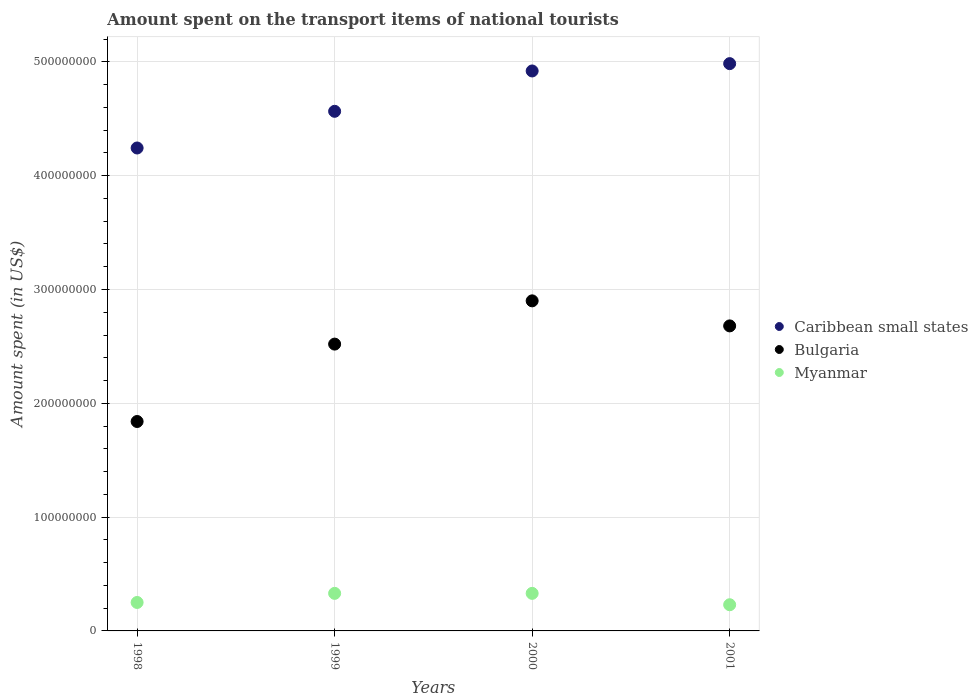What is the amount spent on the transport items of national tourists in Myanmar in 1999?
Keep it short and to the point. 3.30e+07. Across all years, what is the maximum amount spent on the transport items of national tourists in Myanmar?
Offer a terse response. 3.30e+07. Across all years, what is the minimum amount spent on the transport items of national tourists in Caribbean small states?
Make the answer very short. 4.24e+08. What is the total amount spent on the transport items of national tourists in Myanmar in the graph?
Give a very brief answer. 1.14e+08. What is the difference between the amount spent on the transport items of national tourists in Bulgaria in 1998 and that in 2000?
Your response must be concise. -1.06e+08. What is the difference between the amount spent on the transport items of national tourists in Caribbean small states in 1998 and the amount spent on the transport items of national tourists in Bulgaria in 2001?
Your answer should be very brief. 1.56e+08. What is the average amount spent on the transport items of national tourists in Myanmar per year?
Make the answer very short. 2.85e+07. In the year 2001, what is the difference between the amount spent on the transport items of national tourists in Caribbean small states and amount spent on the transport items of national tourists in Myanmar?
Provide a short and direct response. 4.75e+08. In how many years, is the amount spent on the transport items of national tourists in Myanmar greater than 120000000 US$?
Provide a short and direct response. 0. What is the ratio of the amount spent on the transport items of national tourists in Myanmar in 1998 to that in 1999?
Offer a very short reply. 0.76. Is the difference between the amount spent on the transport items of national tourists in Caribbean small states in 1998 and 2001 greater than the difference between the amount spent on the transport items of national tourists in Myanmar in 1998 and 2001?
Give a very brief answer. No. What is the difference between the highest and the second highest amount spent on the transport items of national tourists in Caribbean small states?
Your response must be concise. 6.45e+06. What is the difference between the highest and the lowest amount spent on the transport items of national tourists in Bulgaria?
Offer a very short reply. 1.06e+08. Is the sum of the amount spent on the transport items of national tourists in Myanmar in 1999 and 2001 greater than the maximum amount spent on the transport items of national tourists in Bulgaria across all years?
Give a very brief answer. No. Is it the case that in every year, the sum of the amount spent on the transport items of national tourists in Myanmar and amount spent on the transport items of national tourists in Caribbean small states  is greater than the amount spent on the transport items of national tourists in Bulgaria?
Keep it short and to the point. Yes. Is the amount spent on the transport items of national tourists in Bulgaria strictly less than the amount spent on the transport items of national tourists in Myanmar over the years?
Your response must be concise. No. How many dotlines are there?
Make the answer very short. 3. How many years are there in the graph?
Offer a very short reply. 4. Where does the legend appear in the graph?
Provide a succinct answer. Center right. How many legend labels are there?
Your answer should be compact. 3. How are the legend labels stacked?
Offer a very short reply. Vertical. What is the title of the graph?
Make the answer very short. Amount spent on the transport items of national tourists. What is the label or title of the X-axis?
Provide a short and direct response. Years. What is the label or title of the Y-axis?
Ensure brevity in your answer.  Amount spent (in US$). What is the Amount spent (in US$) of Caribbean small states in 1998?
Offer a terse response. 4.24e+08. What is the Amount spent (in US$) of Bulgaria in 1998?
Provide a short and direct response. 1.84e+08. What is the Amount spent (in US$) of Myanmar in 1998?
Provide a succinct answer. 2.50e+07. What is the Amount spent (in US$) in Caribbean small states in 1999?
Keep it short and to the point. 4.57e+08. What is the Amount spent (in US$) in Bulgaria in 1999?
Your answer should be compact. 2.52e+08. What is the Amount spent (in US$) in Myanmar in 1999?
Ensure brevity in your answer.  3.30e+07. What is the Amount spent (in US$) in Caribbean small states in 2000?
Offer a terse response. 4.92e+08. What is the Amount spent (in US$) in Bulgaria in 2000?
Your answer should be very brief. 2.90e+08. What is the Amount spent (in US$) in Myanmar in 2000?
Make the answer very short. 3.30e+07. What is the Amount spent (in US$) in Caribbean small states in 2001?
Ensure brevity in your answer.  4.98e+08. What is the Amount spent (in US$) of Bulgaria in 2001?
Keep it short and to the point. 2.68e+08. What is the Amount spent (in US$) in Myanmar in 2001?
Provide a short and direct response. 2.30e+07. Across all years, what is the maximum Amount spent (in US$) in Caribbean small states?
Your answer should be compact. 4.98e+08. Across all years, what is the maximum Amount spent (in US$) in Bulgaria?
Keep it short and to the point. 2.90e+08. Across all years, what is the maximum Amount spent (in US$) of Myanmar?
Offer a terse response. 3.30e+07. Across all years, what is the minimum Amount spent (in US$) in Caribbean small states?
Provide a short and direct response. 4.24e+08. Across all years, what is the minimum Amount spent (in US$) of Bulgaria?
Offer a terse response. 1.84e+08. Across all years, what is the minimum Amount spent (in US$) in Myanmar?
Provide a short and direct response. 2.30e+07. What is the total Amount spent (in US$) of Caribbean small states in the graph?
Your answer should be very brief. 1.87e+09. What is the total Amount spent (in US$) of Bulgaria in the graph?
Provide a short and direct response. 9.94e+08. What is the total Amount spent (in US$) in Myanmar in the graph?
Offer a very short reply. 1.14e+08. What is the difference between the Amount spent (in US$) in Caribbean small states in 1998 and that in 1999?
Your response must be concise. -3.22e+07. What is the difference between the Amount spent (in US$) of Bulgaria in 1998 and that in 1999?
Give a very brief answer. -6.80e+07. What is the difference between the Amount spent (in US$) in Myanmar in 1998 and that in 1999?
Ensure brevity in your answer.  -8.00e+06. What is the difference between the Amount spent (in US$) in Caribbean small states in 1998 and that in 2000?
Your answer should be compact. -6.77e+07. What is the difference between the Amount spent (in US$) of Bulgaria in 1998 and that in 2000?
Ensure brevity in your answer.  -1.06e+08. What is the difference between the Amount spent (in US$) of Myanmar in 1998 and that in 2000?
Provide a short and direct response. -8.00e+06. What is the difference between the Amount spent (in US$) in Caribbean small states in 1998 and that in 2001?
Your answer should be compact. -7.41e+07. What is the difference between the Amount spent (in US$) of Bulgaria in 1998 and that in 2001?
Provide a short and direct response. -8.40e+07. What is the difference between the Amount spent (in US$) of Caribbean small states in 1999 and that in 2000?
Ensure brevity in your answer.  -3.54e+07. What is the difference between the Amount spent (in US$) in Bulgaria in 1999 and that in 2000?
Make the answer very short. -3.80e+07. What is the difference between the Amount spent (in US$) in Myanmar in 1999 and that in 2000?
Your response must be concise. 0. What is the difference between the Amount spent (in US$) in Caribbean small states in 1999 and that in 2001?
Make the answer very short. -4.19e+07. What is the difference between the Amount spent (in US$) of Bulgaria in 1999 and that in 2001?
Ensure brevity in your answer.  -1.60e+07. What is the difference between the Amount spent (in US$) of Caribbean small states in 2000 and that in 2001?
Your answer should be compact. -6.45e+06. What is the difference between the Amount spent (in US$) in Bulgaria in 2000 and that in 2001?
Offer a very short reply. 2.20e+07. What is the difference between the Amount spent (in US$) of Caribbean small states in 1998 and the Amount spent (in US$) of Bulgaria in 1999?
Make the answer very short. 1.72e+08. What is the difference between the Amount spent (in US$) of Caribbean small states in 1998 and the Amount spent (in US$) of Myanmar in 1999?
Provide a short and direct response. 3.91e+08. What is the difference between the Amount spent (in US$) of Bulgaria in 1998 and the Amount spent (in US$) of Myanmar in 1999?
Your answer should be compact. 1.51e+08. What is the difference between the Amount spent (in US$) of Caribbean small states in 1998 and the Amount spent (in US$) of Bulgaria in 2000?
Give a very brief answer. 1.34e+08. What is the difference between the Amount spent (in US$) in Caribbean small states in 1998 and the Amount spent (in US$) in Myanmar in 2000?
Offer a very short reply. 3.91e+08. What is the difference between the Amount spent (in US$) of Bulgaria in 1998 and the Amount spent (in US$) of Myanmar in 2000?
Your answer should be compact. 1.51e+08. What is the difference between the Amount spent (in US$) of Caribbean small states in 1998 and the Amount spent (in US$) of Bulgaria in 2001?
Your answer should be compact. 1.56e+08. What is the difference between the Amount spent (in US$) in Caribbean small states in 1998 and the Amount spent (in US$) in Myanmar in 2001?
Provide a short and direct response. 4.01e+08. What is the difference between the Amount spent (in US$) of Bulgaria in 1998 and the Amount spent (in US$) of Myanmar in 2001?
Provide a short and direct response. 1.61e+08. What is the difference between the Amount spent (in US$) of Caribbean small states in 1999 and the Amount spent (in US$) of Bulgaria in 2000?
Make the answer very short. 1.67e+08. What is the difference between the Amount spent (in US$) in Caribbean small states in 1999 and the Amount spent (in US$) in Myanmar in 2000?
Your answer should be very brief. 4.24e+08. What is the difference between the Amount spent (in US$) in Bulgaria in 1999 and the Amount spent (in US$) in Myanmar in 2000?
Give a very brief answer. 2.19e+08. What is the difference between the Amount spent (in US$) of Caribbean small states in 1999 and the Amount spent (in US$) of Bulgaria in 2001?
Keep it short and to the point. 1.89e+08. What is the difference between the Amount spent (in US$) in Caribbean small states in 1999 and the Amount spent (in US$) in Myanmar in 2001?
Your response must be concise. 4.34e+08. What is the difference between the Amount spent (in US$) of Bulgaria in 1999 and the Amount spent (in US$) of Myanmar in 2001?
Ensure brevity in your answer.  2.29e+08. What is the difference between the Amount spent (in US$) in Caribbean small states in 2000 and the Amount spent (in US$) in Bulgaria in 2001?
Keep it short and to the point. 2.24e+08. What is the difference between the Amount spent (in US$) in Caribbean small states in 2000 and the Amount spent (in US$) in Myanmar in 2001?
Provide a short and direct response. 4.69e+08. What is the difference between the Amount spent (in US$) in Bulgaria in 2000 and the Amount spent (in US$) in Myanmar in 2001?
Ensure brevity in your answer.  2.67e+08. What is the average Amount spent (in US$) of Caribbean small states per year?
Provide a succinct answer. 4.68e+08. What is the average Amount spent (in US$) in Bulgaria per year?
Provide a short and direct response. 2.48e+08. What is the average Amount spent (in US$) in Myanmar per year?
Give a very brief answer. 2.85e+07. In the year 1998, what is the difference between the Amount spent (in US$) in Caribbean small states and Amount spent (in US$) in Bulgaria?
Make the answer very short. 2.40e+08. In the year 1998, what is the difference between the Amount spent (in US$) in Caribbean small states and Amount spent (in US$) in Myanmar?
Ensure brevity in your answer.  3.99e+08. In the year 1998, what is the difference between the Amount spent (in US$) of Bulgaria and Amount spent (in US$) of Myanmar?
Give a very brief answer. 1.59e+08. In the year 1999, what is the difference between the Amount spent (in US$) of Caribbean small states and Amount spent (in US$) of Bulgaria?
Your answer should be compact. 2.05e+08. In the year 1999, what is the difference between the Amount spent (in US$) in Caribbean small states and Amount spent (in US$) in Myanmar?
Ensure brevity in your answer.  4.24e+08. In the year 1999, what is the difference between the Amount spent (in US$) of Bulgaria and Amount spent (in US$) of Myanmar?
Your response must be concise. 2.19e+08. In the year 2000, what is the difference between the Amount spent (in US$) of Caribbean small states and Amount spent (in US$) of Bulgaria?
Your answer should be very brief. 2.02e+08. In the year 2000, what is the difference between the Amount spent (in US$) of Caribbean small states and Amount spent (in US$) of Myanmar?
Offer a very short reply. 4.59e+08. In the year 2000, what is the difference between the Amount spent (in US$) of Bulgaria and Amount spent (in US$) of Myanmar?
Your response must be concise. 2.57e+08. In the year 2001, what is the difference between the Amount spent (in US$) in Caribbean small states and Amount spent (in US$) in Bulgaria?
Give a very brief answer. 2.30e+08. In the year 2001, what is the difference between the Amount spent (in US$) in Caribbean small states and Amount spent (in US$) in Myanmar?
Keep it short and to the point. 4.75e+08. In the year 2001, what is the difference between the Amount spent (in US$) in Bulgaria and Amount spent (in US$) in Myanmar?
Provide a succinct answer. 2.45e+08. What is the ratio of the Amount spent (in US$) in Caribbean small states in 1998 to that in 1999?
Offer a terse response. 0.93. What is the ratio of the Amount spent (in US$) in Bulgaria in 1998 to that in 1999?
Your answer should be compact. 0.73. What is the ratio of the Amount spent (in US$) of Myanmar in 1998 to that in 1999?
Make the answer very short. 0.76. What is the ratio of the Amount spent (in US$) in Caribbean small states in 1998 to that in 2000?
Provide a succinct answer. 0.86. What is the ratio of the Amount spent (in US$) of Bulgaria in 1998 to that in 2000?
Your answer should be very brief. 0.63. What is the ratio of the Amount spent (in US$) in Myanmar in 1998 to that in 2000?
Offer a very short reply. 0.76. What is the ratio of the Amount spent (in US$) in Caribbean small states in 1998 to that in 2001?
Your response must be concise. 0.85. What is the ratio of the Amount spent (in US$) of Bulgaria in 1998 to that in 2001?
Your answer should be compact. 0.69. What is the ratio of the Amount spent (in US$) in Myanmar in 1998 to that in 2001?
Offer a very short reply. 1.09. What is the ratio of the Amount spent (in US$) in Caribbean small states in 1999 to that in 2000?
Your response must be concise. 0.93. What is the ratio of the Amount spent (in US$) in Bulgaria in 1999 to that in 2000?
Your response must be concise. 0.87. What is the ratio of the Amount spent (in US$) of Caribbean small states in 1999 to that in 2001?
Your answer should be compact. 0.92. What is the ratio of the Amount spent (in US$) of Bulgaria in 1999 to that in 2001?
Ensure brevity in your answer.  0.94. What is the ratio of the Amount spent (in US$) in Myanmar in 1999 to that in 2001?
Make the answer very short. 1.43. What is the ratio of the Amount spent (in US$) of Caribbean small states in 2000 to that in 2001?
Make the answer very short. 0.99. What is the ratio of the Amount spent (in US$) in Bulgaria in 2000 to that in 2001?
Provide a succinct answer. 1.08. What is the ratio of the Amount spent (in US$) in Myanmar in 2000 to that in 2001?
Offer a terse response. 1.43. What is the difference between the highest and the second highest Amount spent (in US$) in Caribbean small states?
Give a very brief answer. 6.45e+06. What is the difference between the highest and the second highest Amount spent (in US$) in Bulgaria?
Ensure brevity in your answer.  2.20e+07. What is the difference between the highest and the second highest Amount spent (in US$) in Myanmar?
Offer a very short reply. 0. What is the difference between the highest and the lowest Amount spent (in US$) of Caribbean small states?
Ensure brevity in your answer.  7.41e+07. What is the difference between the highest and the lowest Amount spent (in US$) in Bulgaria?
Ensure brevity in your answer.  1.06e+08. 